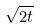<formula> <loc_0><loc_0><loc_500><loc_500>\sqrt { 2 t }</formula> 